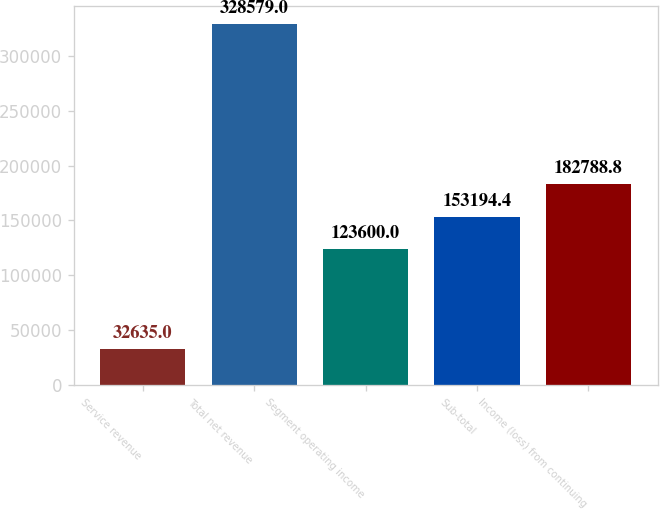Convert chart. <chart><loc_0><loc_0><loc_500><loc_500><bar_chart><fcel>Service revenue<fcel>Total net revenue<fcel>Segment operating income<fcel>Sub-total<fcel>Income (loss) from continuing<nl><fcel>32635<fcel>328579<fcel>123600<fcel>153194<fcel>182789<nl></chart> 